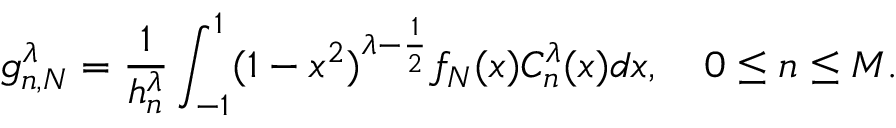Convert formula to latex. <formula><loc_0><loc_0><loc_500><loc_500>g _ { n , N } ^ { \lambda } = \frac { 1 } { h _ { n } ^ { \lambda } } \int _ { - 1 } ^ { 1 } ( 1 - x ^ { 2 } ) ^ { \lambda - \frac { 1 } { 2 } } f _ { N } ( x ) C _ { n } ^ { \lambda } ( x ) d x , \quad 0 \leq n \leq M .</formula> 